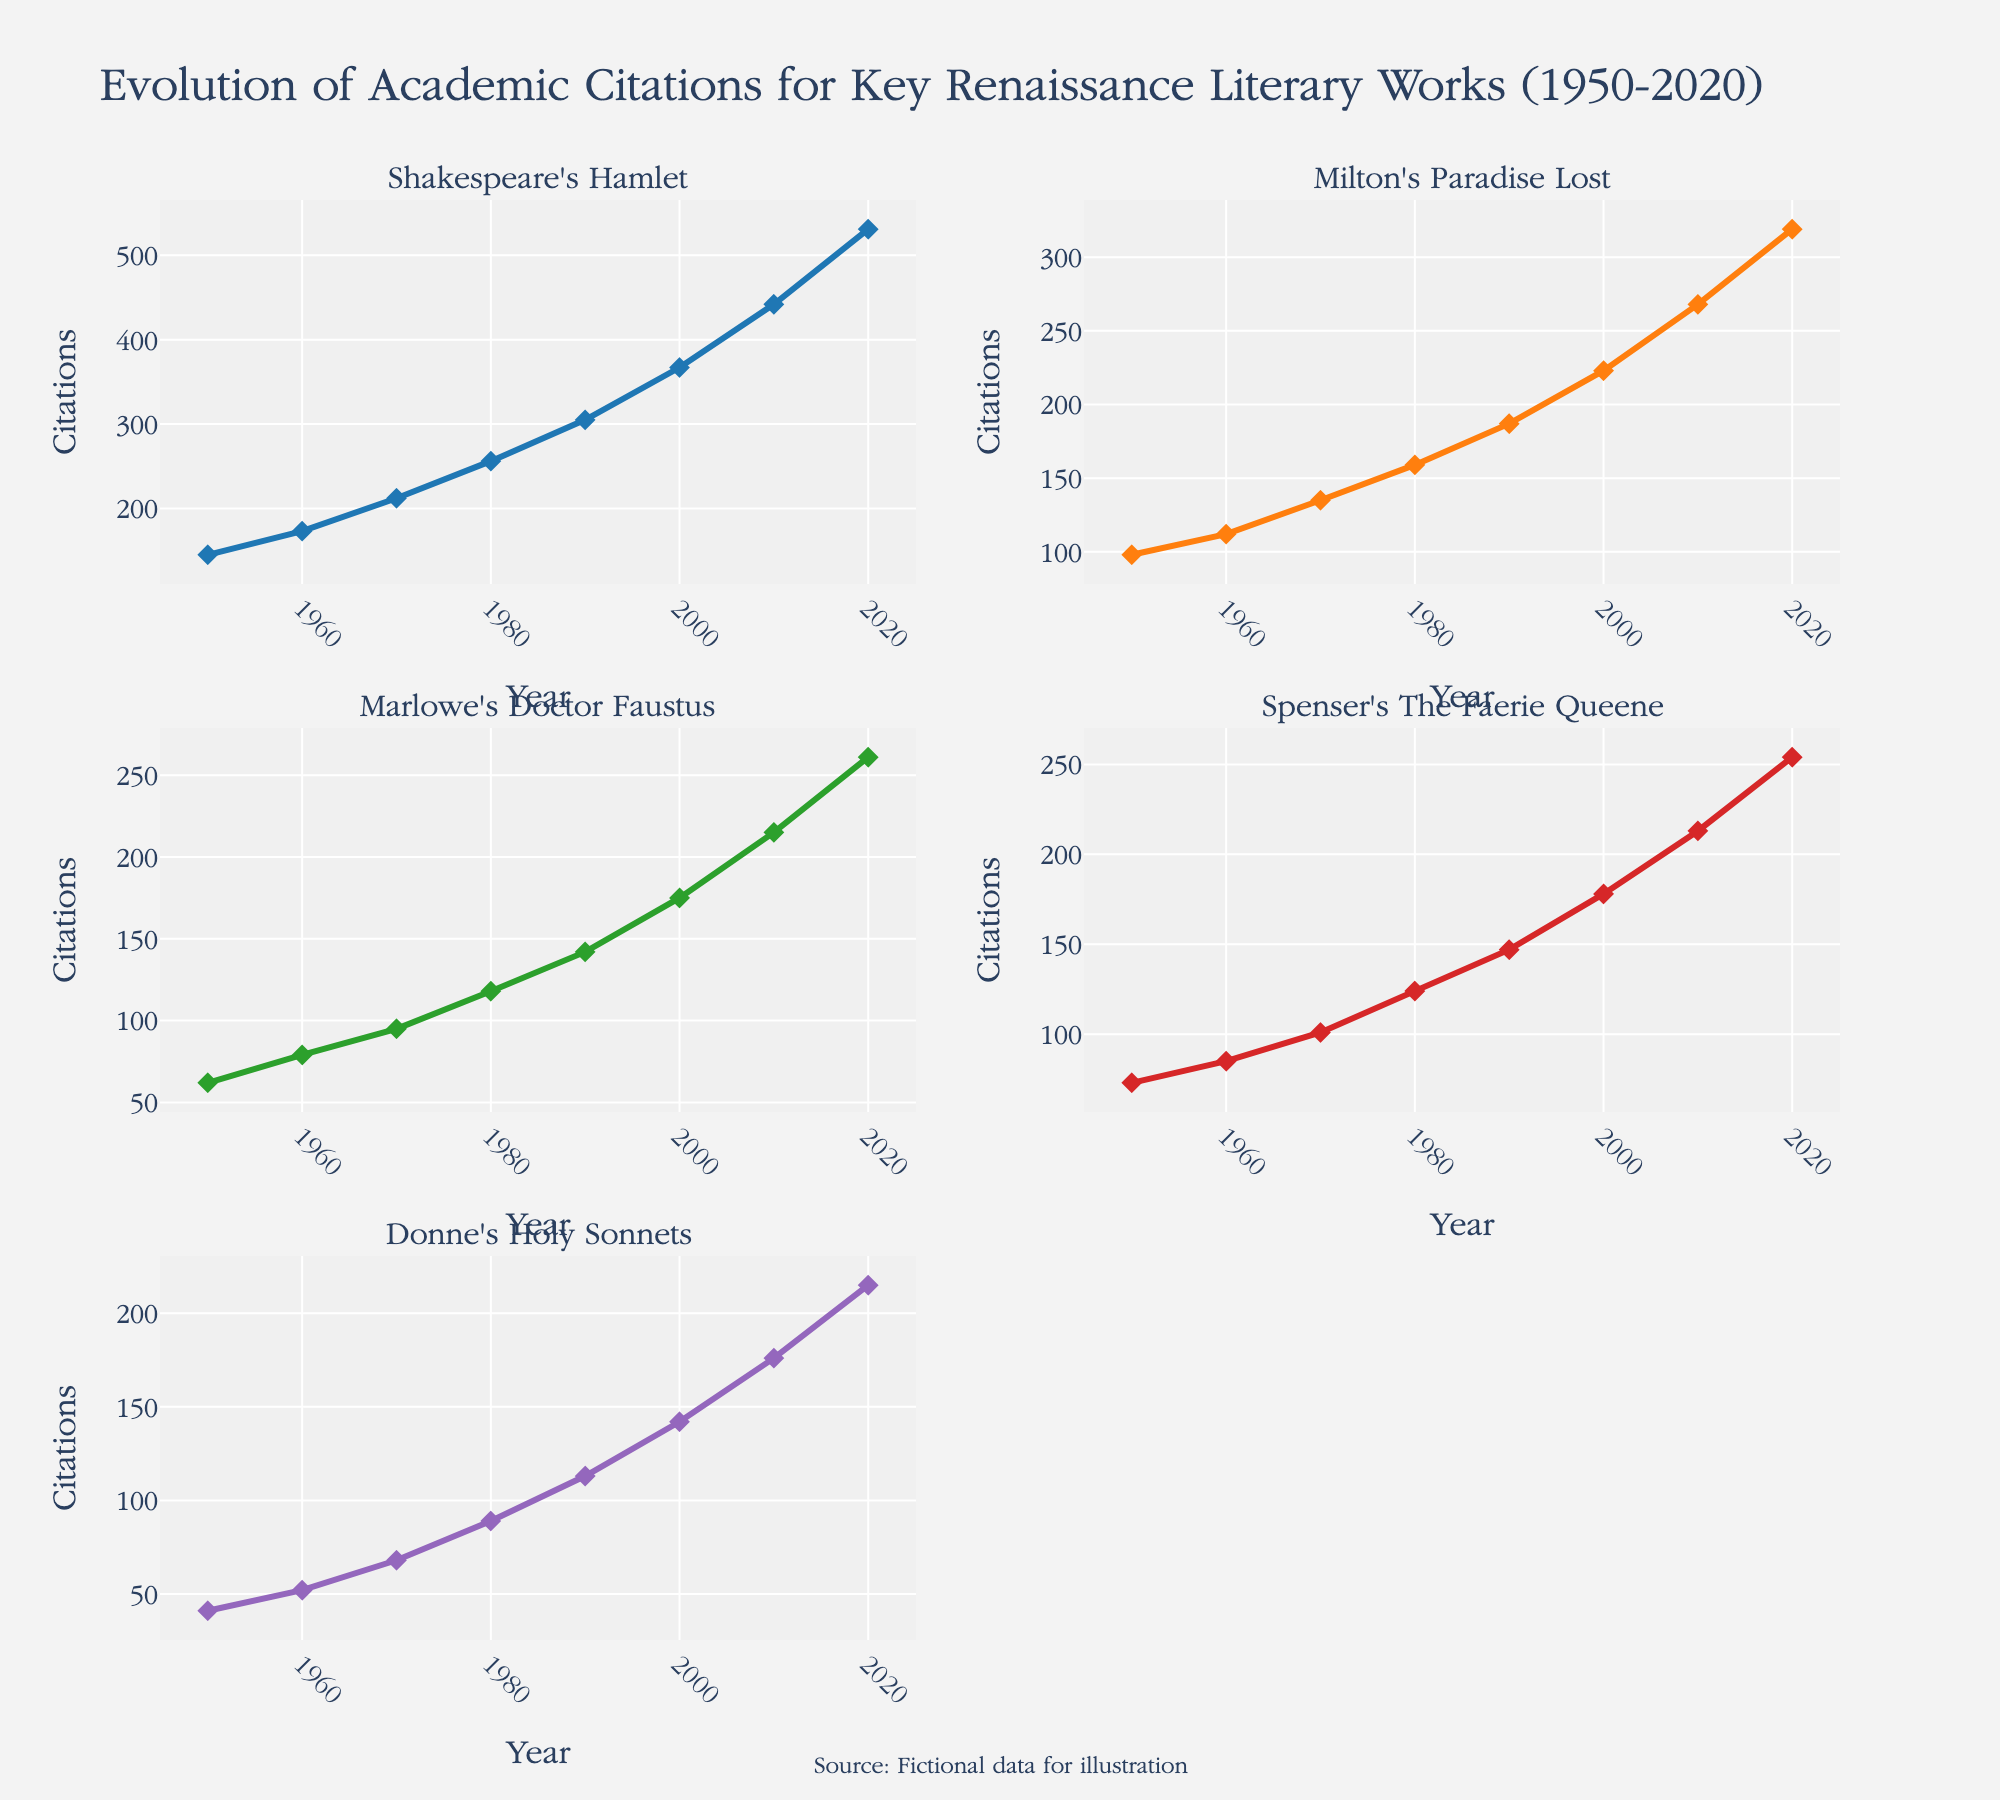What's the title of the figure? The title is located at the top of the figure. It reads "Evolution of Academic Citations for Key Renaissance Literary Works (1950-2020)."
Answer: Evolution of Academic Citations for Key Renaissance Literary Works (1950-2020) Which literary work had the most citations in 2020? By examining the highest point on the y-axis for the year 2020 across all subplots, we can see that Shakespeare's Hamlet had the most citations.
Answer: Shakespeare's Hamlet What is the total number of citations for Donne's Holy Sonnets in 1980? Look at the subplot for Donne's Holy Sonnets and find the data point for the year 1980, which is 89 citations.
Answer: 89 How much did the citations for Marlowe's Doctor Faustus increase from 1950 to 2010? Find the citation count for Marlowe's Doctor Faustus in 1950 (62) and in 2010 (215), then subtract the earlier value from the later one: 215 - 62 = 153.
Answer: 153 Which literary work experienced the smallest increase in citations from 1950 to 2020? Calculate the increase for each work: 
Shakespeare's Hamlet: 531 - 145 = 386 
Milton's Paradise Lost: 319 - 98 = 221 
Marlowe's Doctor Faustus: 261 - 62 = 199 
Spenser's The Faerie Queene: 254 - 73 = 181 
Donne's Holy Sonnets: 215 - 41 = 174 
The smallest increase is for Donne's Holy Sonnets, with an increase of 174 citations.
Answer: Donne's Holy Sonnets Between 2000 and 2020, which literary work had the greatest increase in citations? Calculate the increase for each work between 2000 and 2020:
Shakespeare's Hamlet: 531 - 367 = 164
Milton's Paradise Lost: 319 - 223 = 96
Marlowe's Doctor Faustus: 261 - 175 = 86
Spenser's The Faerie Queene: 254 - 178 = 76
Donne's Holy Sonnets: 215 - 142 = 73
The greatest increase is for Shakespeare's Hamlet with an increase of 164 citations.
Answer: Shakespeare's Hamlet In which decade did Milton's Paradise Lost see the highest growth in citations? Calculate the growth for each decade by subtracting the starting value of the decade from the ending value and find the highest:
1950-1960: 112 - 98 = 14
1960-1970: 135 - 112 = 23
1970-1980: 159 - 135 = 24
1980-1990: 187 - 159 = 28
1990-2000: 223 - 187 = 36
2000-2010: 268 - 223 = 45
2010-2020: 319 - 268 = 51
The highest growth occurred between 2010 and 2020 with a growth of 51 citations.
Answer: 2010-2020 Compare the trend lines of Spenser's The Faerie Queene and Marlowe's Doctor Faustus. Which one has a steeper rise in citations from 1950 to 2020? Notice the overall change in citations from 1950 to 2020 for each work:
Spenser's The Faerie Queene: 254 - 73 = 181
Marlowe's Doctor Faustus: 261 - 62 = 199
A steeper rise would be indicated by the larger increase in citations, which is for Marlowe's Doctor Faustus with 199 citations.
Answer: Marlowe's Doctor Faustus What's the average number of citations for Shakespeare's Hamlet across all recorded years? Sum up the citation values for Shakespeare's Hamlet (145 + 173 + 212 + 256 + 305 + 367 + 442 + 531) = 2431, and then divide by the number of data points (8): 2431 / 8 = 303.875.
Answer: 303.875 